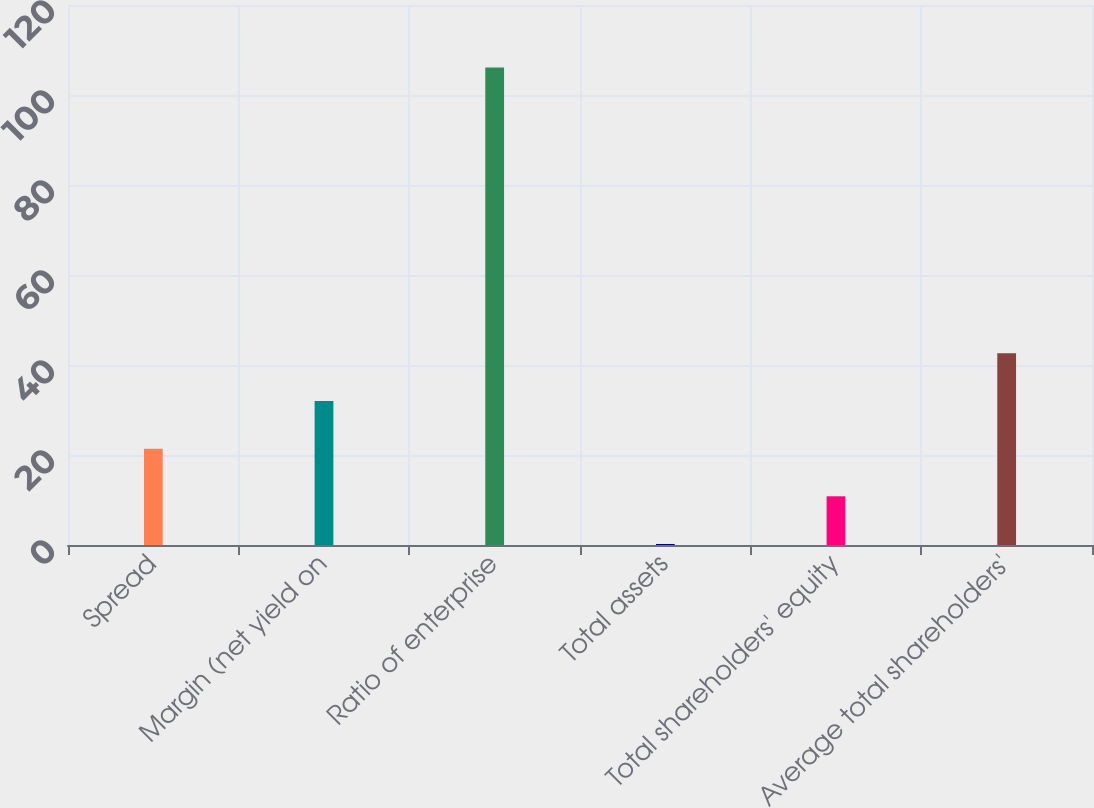Convert chart. <chart><loc_0><loc_0><loc_500><loc_500><bar_chart><fcel>Spread<fcel>Margin (net yield on<fcel>Ratio of enterprise<fcel>Total assets<fcel>Total shareholders' equity<fcel>Average total shareholders'<nl><fcel>21.41<fcel>32<fcel>106.09<fcel>0.23<fcel>10.82<fcel>42.59<nl></chart> 